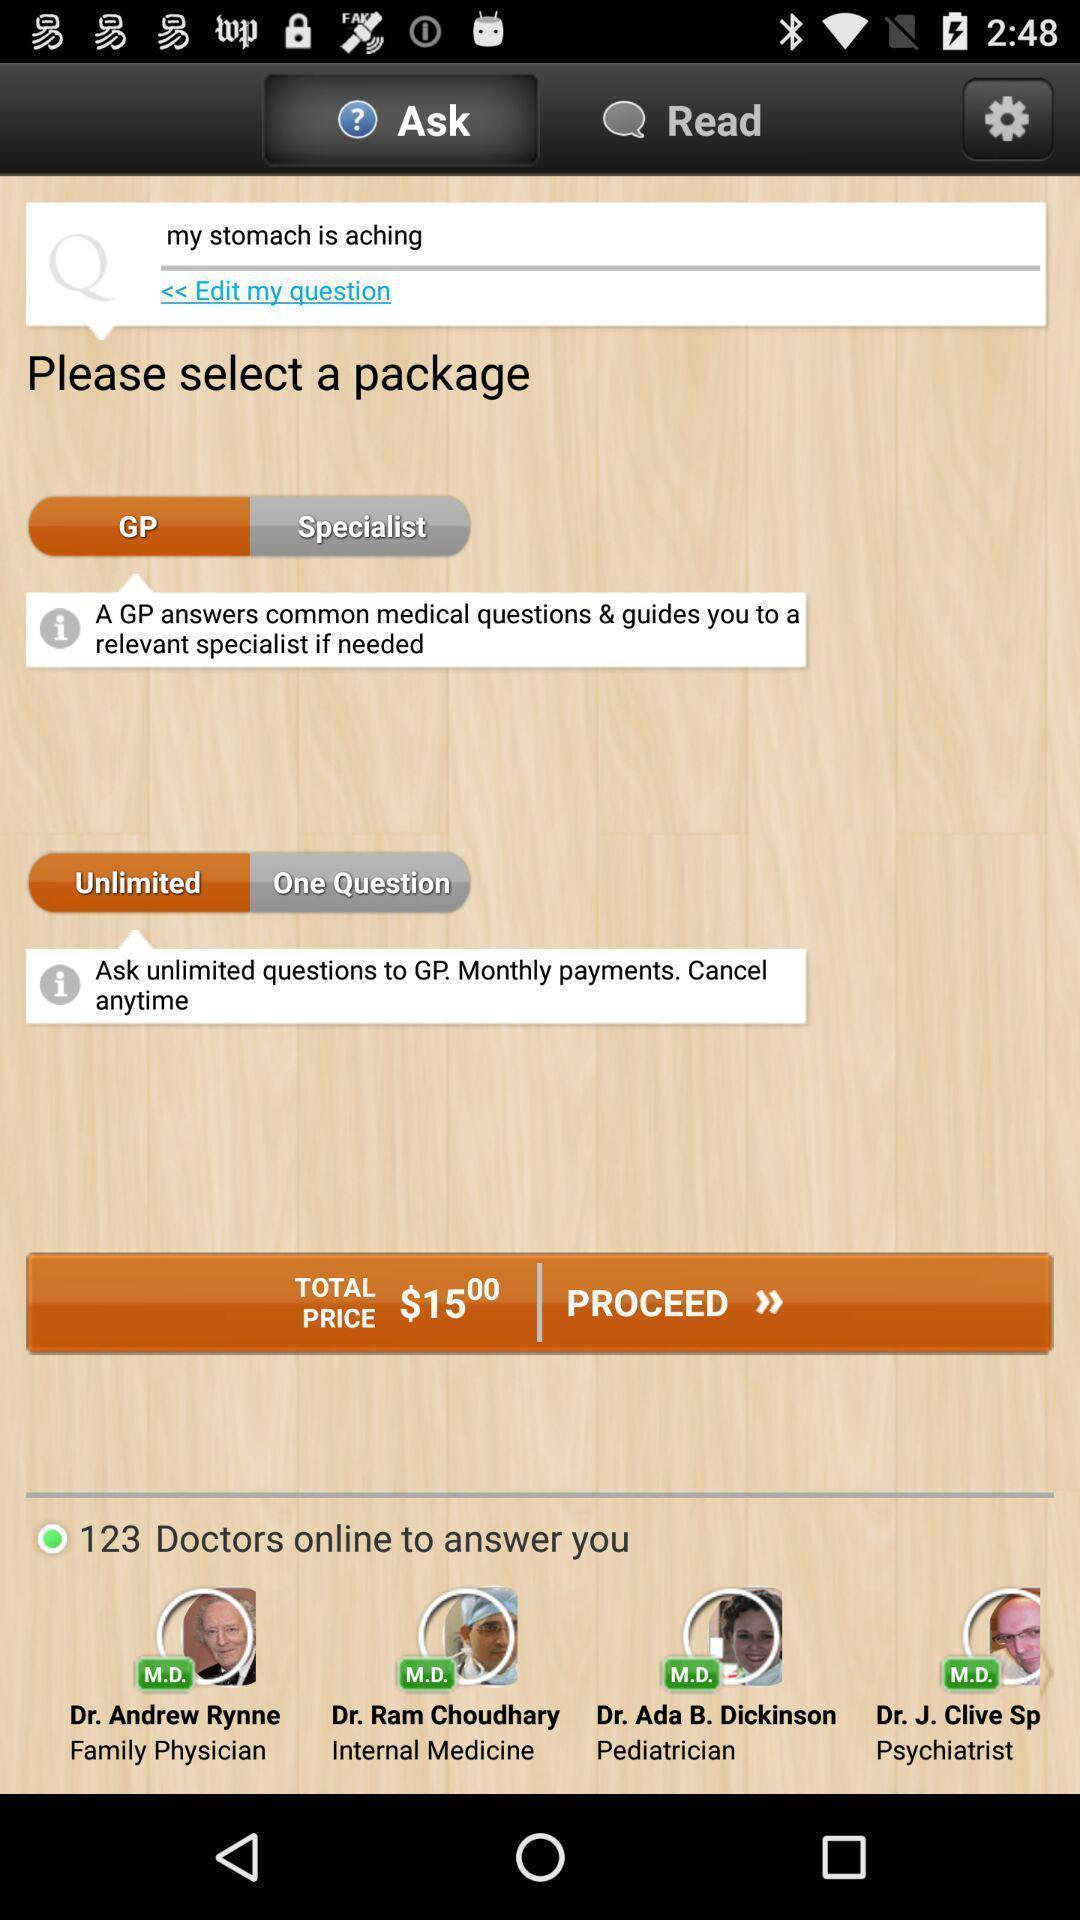What can you discern from this picture? Page showing information from a medical app. 